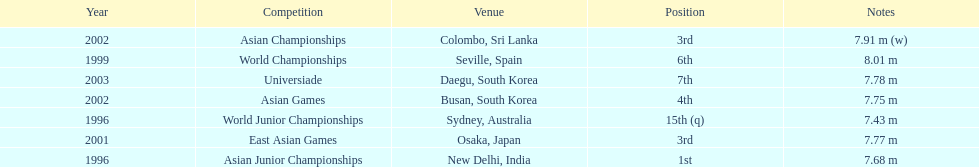Which year was his best jump? 1999. 